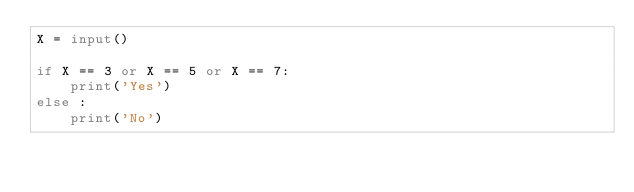<code> <loc_0><loc_0><loc_500><loc_500><_Python_>X = input()

if X == 3 or X == 5 or X == 7:
	print('Yes')
else :
	print('No')</code> 